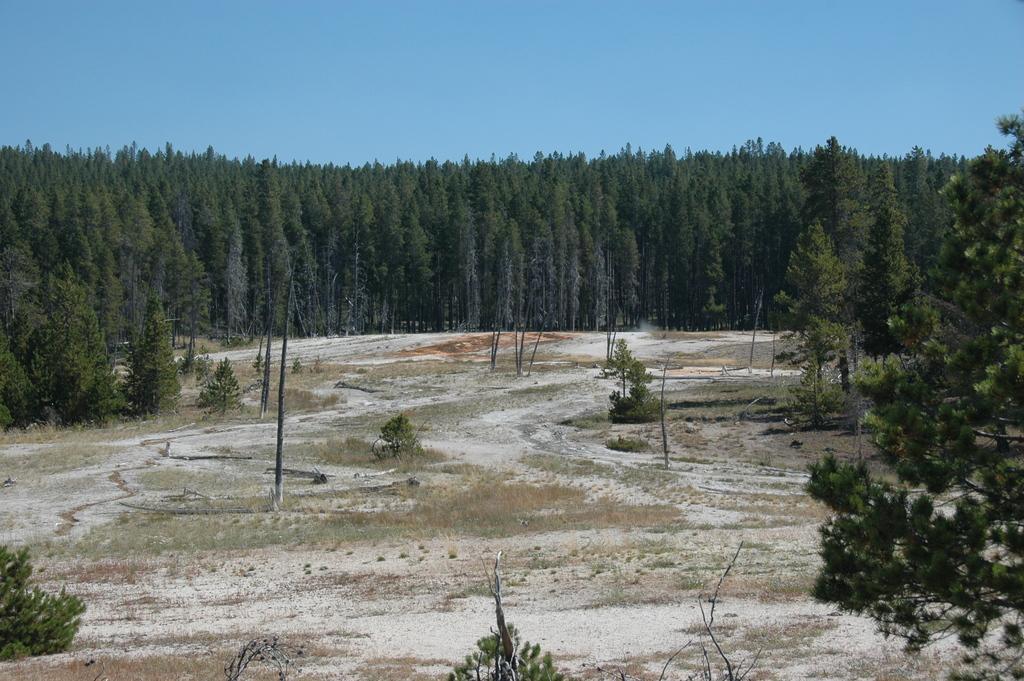Can you describe this image briefly? The image might be taken in a forest. In the foreground of the picture there are trees, plants, grass and soil. In the middle of the picture there are trees. At the top it is sky. 